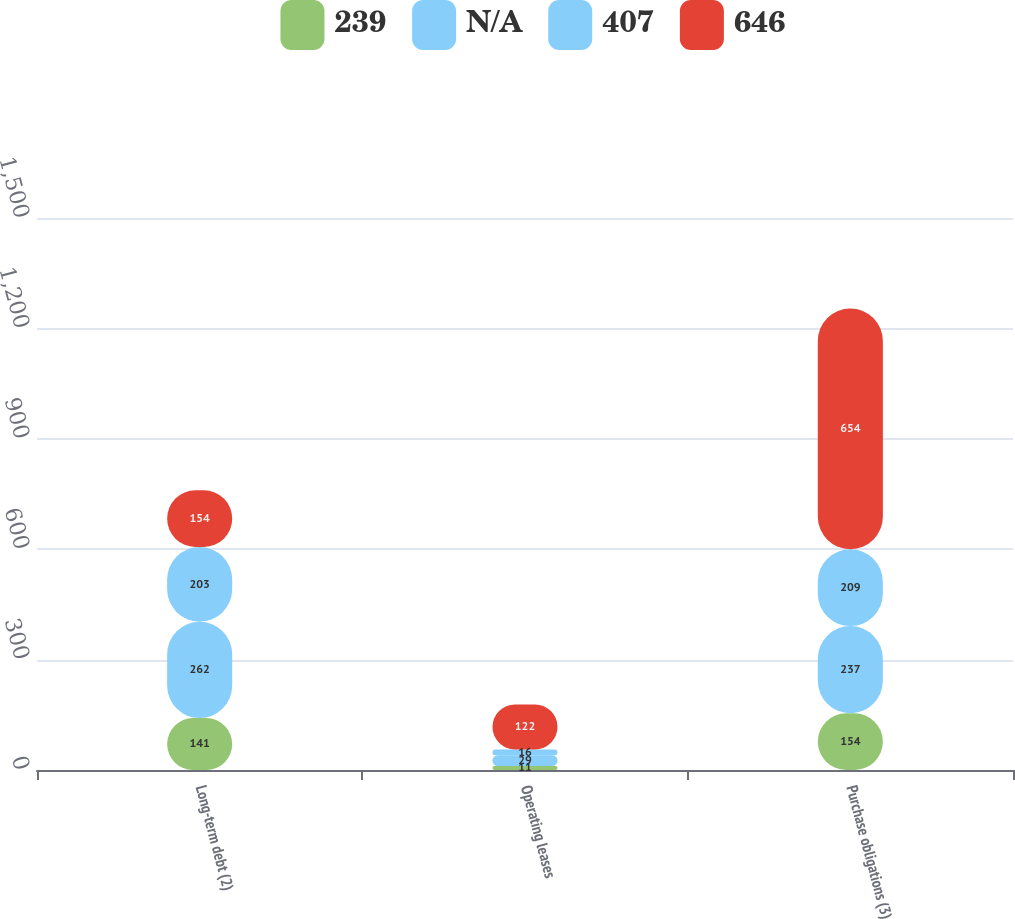Convert chart. <chart><loc_0><loc_0><loc_500><loc_500><stacked_bar_chart><ecel><fcel>Long-term debt (2)<fcel>Operating leases<fcel>Purchase obligations (3)<nl><fcel>239<fcel>141<fcel>11<fcel>154<nl><fcel>nan<fcel>262<fcel>29<fcel>237<nl><fcel>407<fcel>203<fcel>16<fcel>209<nl><fcel>646<fcel>154<fcel>122<fcel>654<nl></chart> 